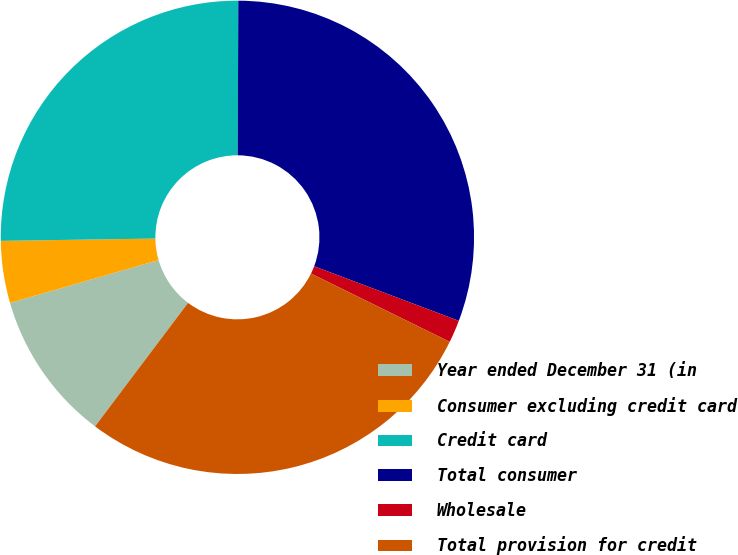Convert chart to OTSL. <chart><loc_0><loc_0><loc_500><loc_500><pie_chart><fcel>Year ended December 31 (in<fcel>Consumer excluding credit card<fcel>Credit card<fcel>Total consumer<fcel>Wholesale<fcel>Total provision for credit<nl><fcel>10.26%<fcel>4.23%<fcel>25.3%<fcel>30.68%<fcel>1.54%<fcel>27.99%<nl></chart> 